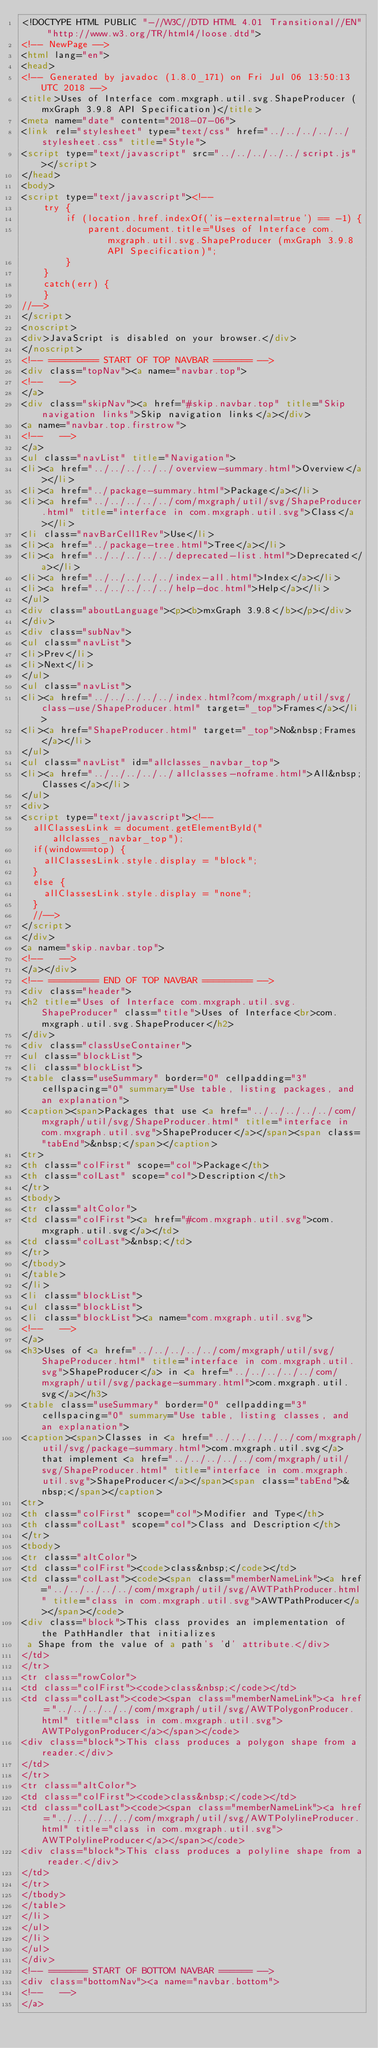Convert code to text. <code><loc_0><loc_0><loc_500><loc_500><_HTML_><!DOCTYPE HTML PUBLIC "-//W3C//DTD HTML 4.01 Transitional//EN" "http://www.w3.org/TR/html4/loose.dtd">
<!-- NewPage -->
<html lang="en">
<head>
<!-- Generated by javadoc (1.8.0_171) on Fri Jul 06 13:50:13 UTC 2018 -->
<title>Uses of Interface com.mxgraph.util.svg.ShapeProducer (mxGraph 3.9.8 API Specification)</title>
<meta name="date" content="2018-07-06">
<link rel="stylesheet" type="text/css" href="../../../../../stylesheet.css" title="Style">
<script type="text/javascript" src="../../../../../script.js"></script>
</head>
<body>
<script type="text/javascript"><!--
    try {
        if (location.href.indexOf('is-external=true') == -1) {
            parent.document.title="Uses of Interface com.mxgraph.util.svg.ShapeProducer (mxGraph 3.9.8 API Specification)";
        }
    }
    catch(err) {
    }
//-->
</script>
<noscript>
<div>JavaScript is disabled on your browser.</div>
</noscript>
<!-- ========= START OF TOP NAVBAR ======= -->
<div class="topNav"><a name="navbar.top">
<!--   -->
</a>
<div class="skipNav"><a href="#skip.navbar.top" title="Skip navigation links">Skip navigation links</a></div>
<a name="navbar.top.firstrow">
<!--   -->
</a>
<ul class="navList" title="Navigation">
<li><a href="../../../../../overview-summary.html">Overview</a></li>
<li><a href="../package-summary.html">Package</a></li>
<li><a href="../../../../../com/mxgraph/util/svg/ShapeProducer.html" title="interface in com.mxgraph.util.svg">Class</a></li>
<li class="navBarCell1Rev">Use</li>
<li><a href="../package-tree.html">Tree</a></li>
<li><a href="../../../../../deprecated-list.html">Deprecated</a></li>
<li><a href="../../../../../index-all.html">Index</a></li>
<li><a href="../../../../../help-doc.html">Help</a></li>
</ul>
<div class="aboutLanguage"><p><b>mxGraph 3.9.8</b></p></div>
</div>
<div class="subNav">
<ul class="navList">
<li>Prev</li>
<li>Next</li>
</ul>
<ul class="navList">
<li><a href="../../../../../index.html?com/mxgraph/util/svg/class-use/ShapeProducer.html" target="_top">Frames</a></li>
<li><a href="ShapeProducer.html" target="_top">No&nbsp;Frames</a></li>
</ul>
<ul class="navList" id="allclasses_navbar_top">
<li><a href="../../../../../allclasses-noframe.html">All&nbsp;Classes</a></li>
</ul>
<div>
<script type="text/javascript"><!--
  allClassesLink = document.getElementById("allclasses_navbar_top");
  if(window==top) {
    allClassesLink.style.display = "block";
  }
  else {
    allClassesLink.style.display = "none";
  }
  //-->
</script>
</div>
<a name="skip.navbar.top">
<!--   -->
</a></div>
<!-- ========= END OF TOP NAVBAR ========= -->
<div class="header">
<h2 title="Uses of Interface com.mxgraph.util.svg.ShapeProducer" class="title">Uses of Interface<br>com.mxgraph.util.svg.ShapeProducer</h2>
</div>
<div class="classUseContainer">
<ul class="blockList">
<li class="blockList">
<table class="useSummary" border="0" cellpadding="3" cellspacing="0" summary="Use table, listing packages, and an explanation">
<caption><span>Packages that use <a href="../../../../../com/mxgraph/util/svg/ShapeProducer.html" title="interface in com.mxgraph.util.svg">ShapeProducer</a></span><span class="tabEnd">&nbsp;</span></caption>
<tr>
<th class="colFirst" scope="col">Package</th>
<th class="colLast" scope="col">Description</th>
</tr>
<tbody>
<tr class="altColor">
<td class="colFirst"><a href="#com.mxgraph.util.svg">com.mxgraph.util.svg</a></td>
<td class="colLast">&nbsp;</td>
</tr>
</tbody>
</table>
</li>
<li class="blockList">
<ul class="blockList">
<li class="blockList"><a name="com.mxgraph.util.svg">
<!--   -->
</a>
<h3>Uses of <a href="../../../../../com/mxgraph/util/svg/ShapeProducer.html" title="interface in com.mxgraph.util.svg">ShapeProducer</a> in <a href="../../../../../com/mxgraph/util/svg/package-summary.html">com.mxgraph.util.svg</a></h3>
<table class="useSummary" border="0" cellpadding="3" cellspacing="0" summary="Use table, listing classes, and an explanation">
<caption><span>Classes in <a href="../../../../../com/mxgraph/util/svg/package-summary.html">com.mxgraph.util.svg</a> that implement <a href="../../../../../com/mxgraph/util/svg/ShapeProducer.html" title="interface in com.mxgraph.util.svg">ShapeProducer</a></span><span class="tabEnd">&nbsp;</span></caption>
<tr>
<th class="colFirst" scope="col">Modifier and Type</th>
<th class="colLast" scope="col">Class and Description</th>
</tr>
<tbody>
<tr class="altColor">
<td class="colFirst"><code>class&nbsp;</code></td>
<td class="colLast"><code><span class="memberNameLink"><a href="../../../../../com/mxgraph/util/svg/AWTPathProducer.html" title="class in com.mxgraph.util.svg">AWTPathProducer</a></span></code>
<div class="block">This class provides an implementation of the PathHandler that initializes
 a Shape from the value of a path's 'd' attribute.</div>
</td>
</tr>
<tr class="rowColor">
<td class="colFirst"><code>class&nbsp;</code></td>
<td class="colLast"><code><span class="memberNameLink"><a href="../../../../../com/mxgraph/util/svg/AWTPolygonProducer.html" title="class in com.mxgraph.util.svg">AWTPolygonProducer</a></span></code>
<div class="block">This class produces a polygon shape from a reader.</div>
</td>
</tr>
<tr class="altColor">
<td class="colFirst"><code>class&nbsp;</code></td>
<td class="colLast"><code><span class="memberNameLink"><a href="../../../../../com/mxgraph/util/svg/AWTPolylineProducer.html" title="class in com.mxgraph.util.svg">AWTPolylineProducer</a></span></code>
<div class="block">This class produces a polyline shape from a reader.</div>
</td>
</tr>
</tbody>
</table>
</li>
</ul>
</li>
</ul>
</div>
<!-- ======= START OF BOTTOM NAVBAR ====== -->
<div class="bottomNav"><a name="navbar.bottom">
<!--   -->
</a></code> 